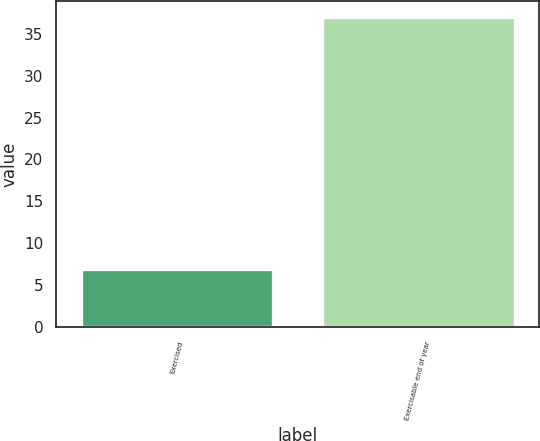Convert chart. <chart><loc_0><loc_0><loc_500><loc_500><bar_chart><fcel>Exercised<fcel>Exercisable end of year<nl><fcel>7<fcel>37<nl></chart> 